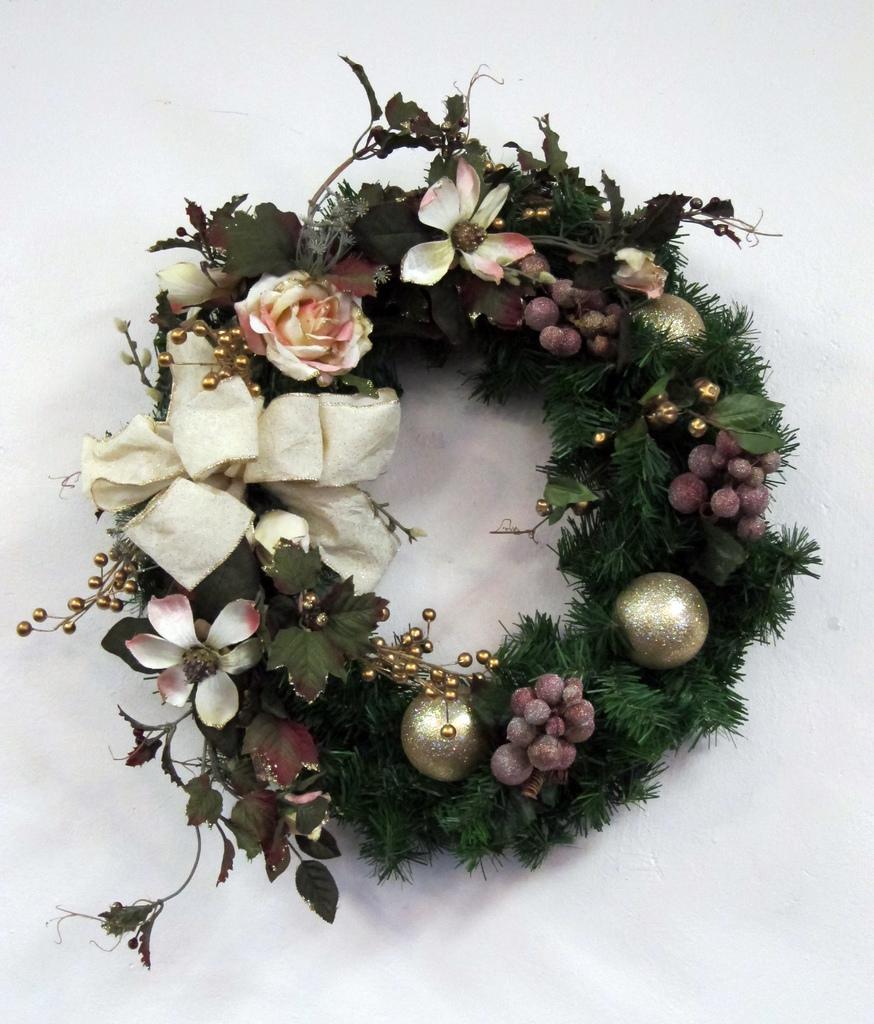Could you give a brief overview of what you see in this image? In this picture I can see a wreath on an object. 